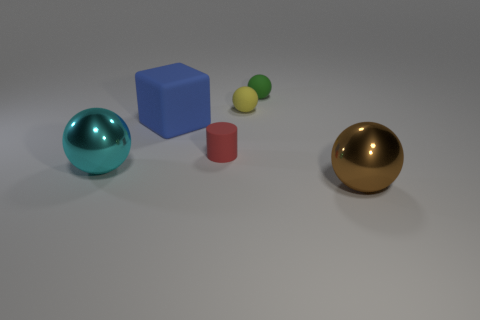Add 1 red rubber blocks. How many objects exist? 7 Subtract all cylinders. How many objects are left? 5 Add 5 brown balls. How many brown balls are left? 6 Add 6 small red rubber cylinders. How many small red rubber cylinders exist? 7 Subtract 0 brown cylinders. How many objects are left? 6 Subtract all tiny blue balls. Subtract all matte things. How many objects are left? 2 